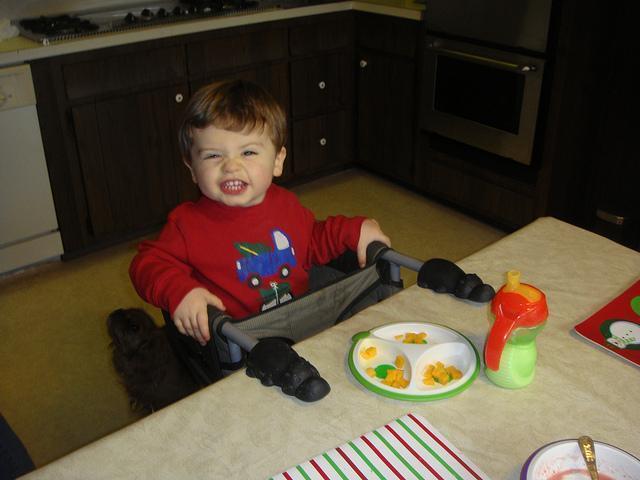What kind of plate is the boy using?
Make your selection and explain in format: 'Answer: answer
Rationale: rationale.'
Options: Muppet, soup, divider, bread. Answer: divider.
Rationale: A kid is sitting in front of a plate that is sectioned of into areas so the food doesn't touch. 